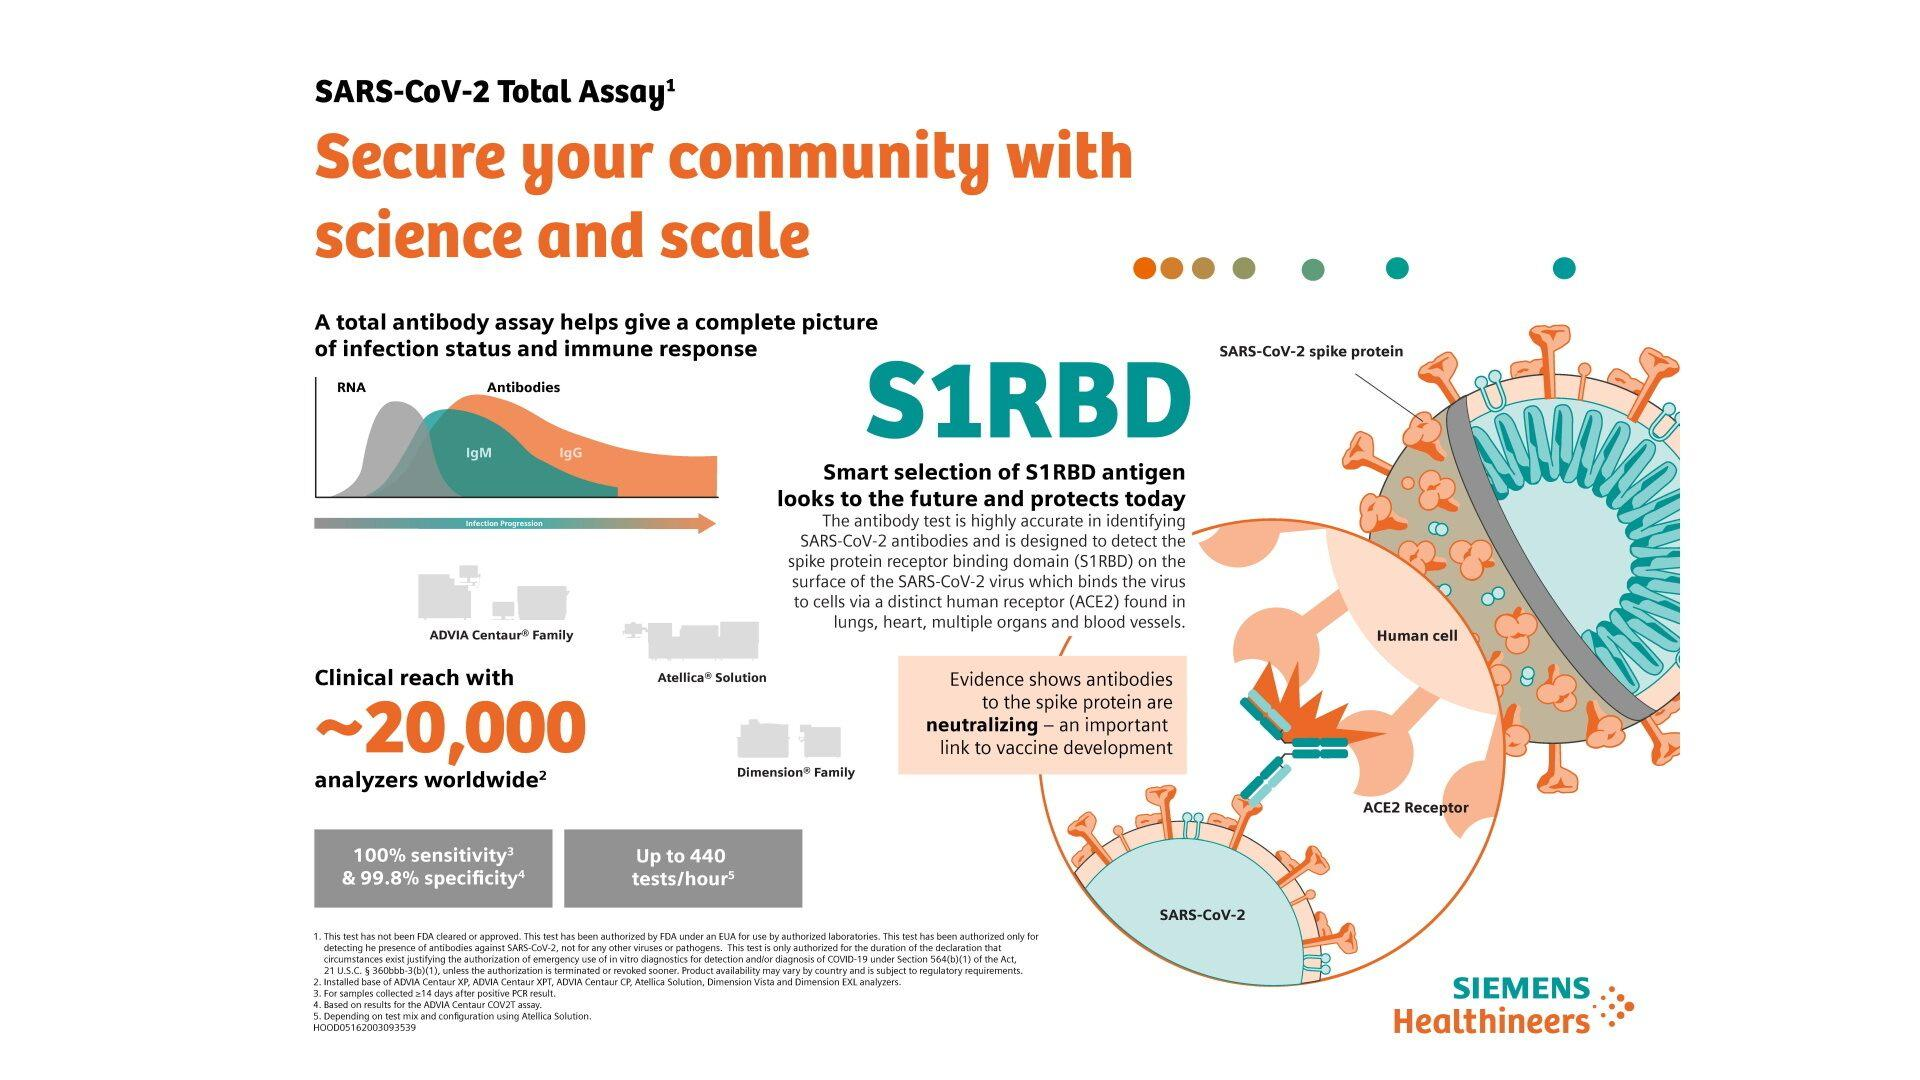Indicate a few pertinent items in this graphic. The Corona virus primarily enters human cells through the distinct human receptor called ACE2. The color code assigned to IgM antibody is green. The COV2T assay can perform up to 440 antibody tests per hour. The infographic lists several antibodies, including IgM and IgG. The ACE2 receptor is primarily found in the lungs and heart. 